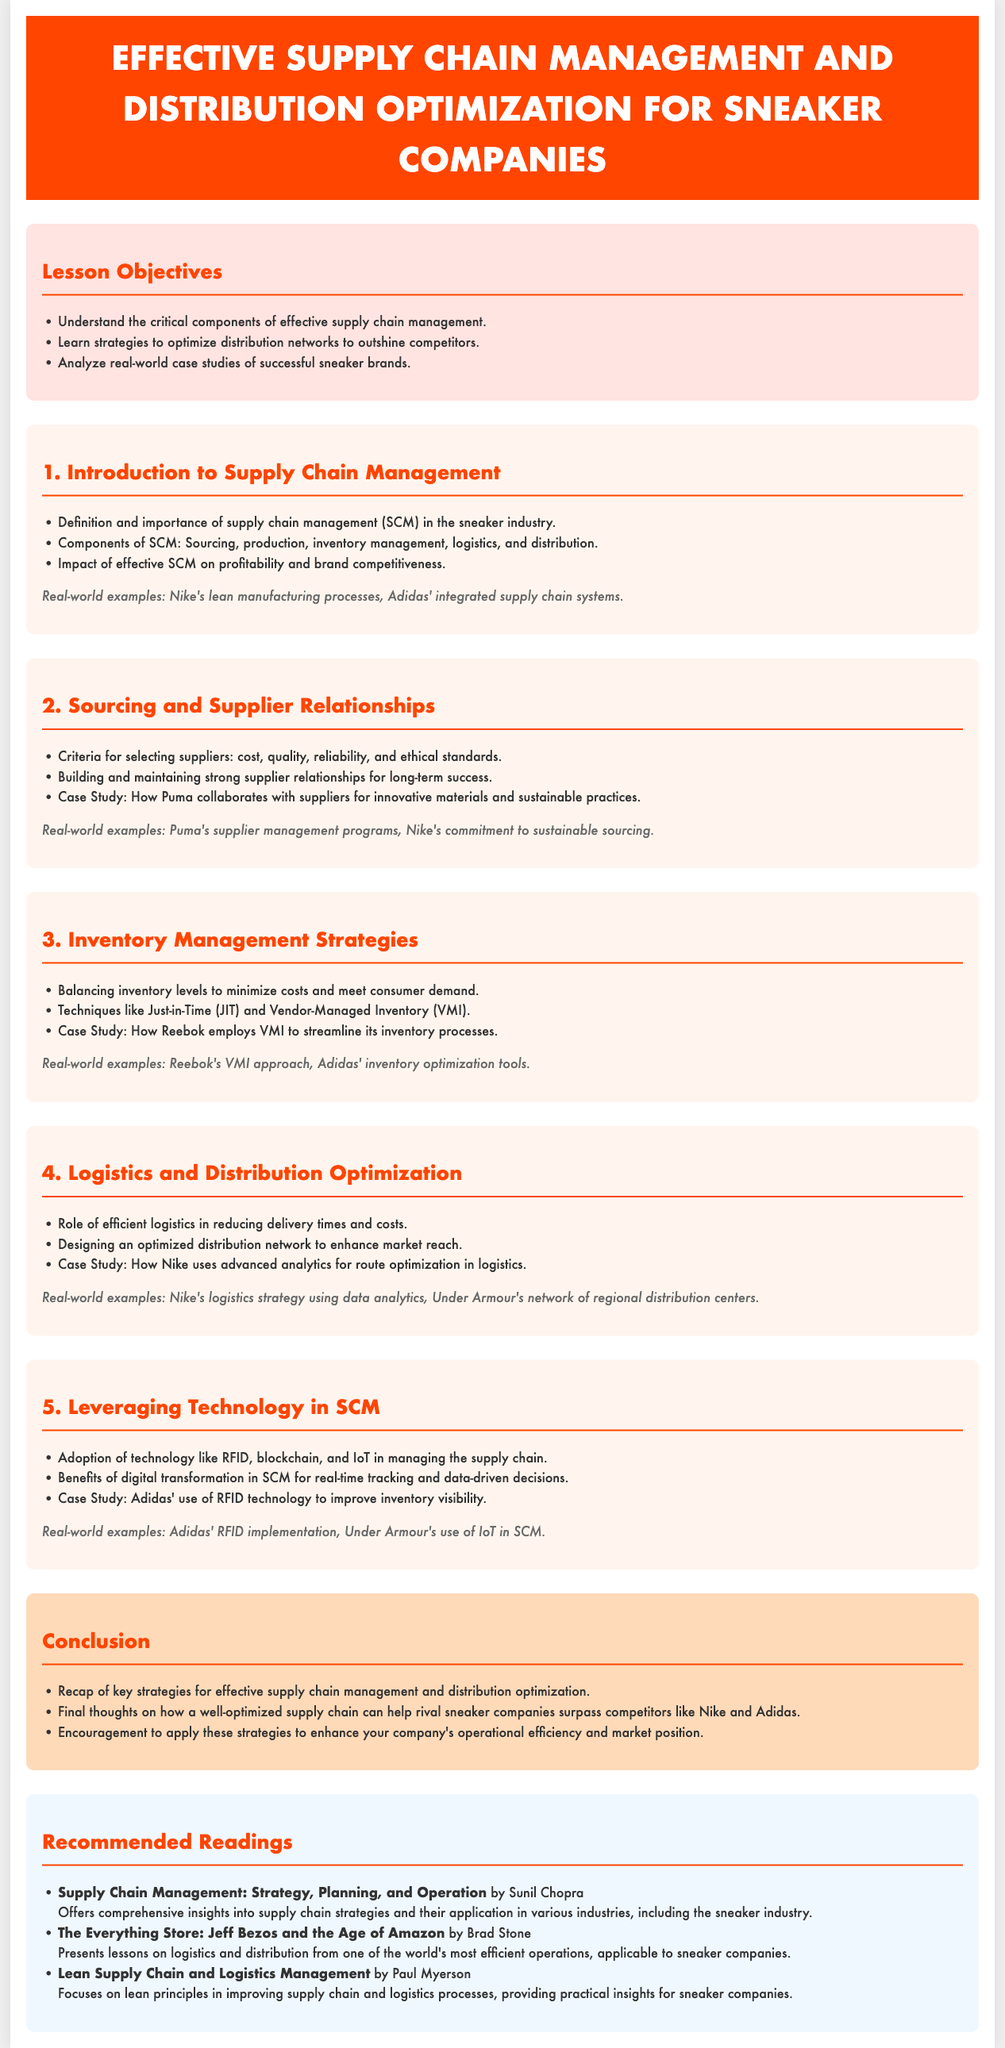what is the title of the lesson plan? The title of the lesson plan is indicated in the header of the document.
Answer: Effective Supply Chain Management and Distribution Optimization for Sneaker Companies what is one key component of supply chain management? The document lists several components of supply chain management, identifiable in the introduction section.
Answer: Sourcing which case study highlights Puma's approach to suppliers? The document mentions a specific case study demonstrating Puma's practices in relation to suppliers.
Answer: How Puma collaborates with suppliers for innovative materials and sustainable practices what technology is highlighted for inventory visibility? The lesson discusses the use of a specific technology that improves inventory visibility in a case study.
Answer: RFID how does the lesson plan suggest distribution networks should be optimized? The objectives of the lesson plan mention a strategy regarding distribution networks.
Answer: To outshine competitors what is one benefit of digital transformation in supply chain management? The document states a specific benefit of adopting technology within supply chain management.
Answer: Real-time tracking which company uses advanced analytics for route optimization? The lesson plan provides an example of a company that employs advanced analytics for logistics purposes.
Answer: Nike how many recommended readings are listed in the document? The document includes a section for recommended readings, which details how many there are.
Answer: Three 